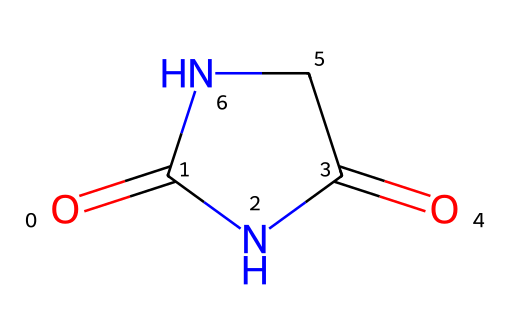What is the molecular formula of hydantoin? To determine the molecular formula, we count the number of each type of atom in the structure represented by the SMILES notation. The SMILES shows 2 carbon atoms (C), 4 hydrogen atoms (H), 2 nitrogen atoms (N), and 2 oxygen atoms (O). Therefore, the molecular formula is C2H4N2O2.
Answer: C2H4N2O2 How many nitrogen atoms are in this structure? Observing the SMILES notation, we identify that there are 2 nitrogen (N) atoms present in the structure.
Answer: 2 What type of functional groups are present in hydantoin? The structure contains imide (two carbonyls connected by a nitrogen) as indicated by the specific arrangement in the SMILES code. It also has two carbonyl groups, which are part of imide functional group classification.
Answer: imide What is the total number of rings in the structure of hydantoin? Analyzing the structure, it is clear that there is one cyclic structure formed by the bonding of carbon and nitrogen, which creates a ring system as denoted by the "C1" notation in the SMILES.
Answer: 1 Does hydantoin have any stereocenters? In examining the structure, we notice that there are no carbon atoms attached to four different substituents, which means there are no stereocenters.
Answer: no What characteristic makes hydantoin an imide? The defining characteristic of hydantoin being an imide is the presence of two carbonyl groups (C=O) bonded to nitrogen atoms in a cyclic formation, which is represented in the structure.
Answer: two carbonyl groups 